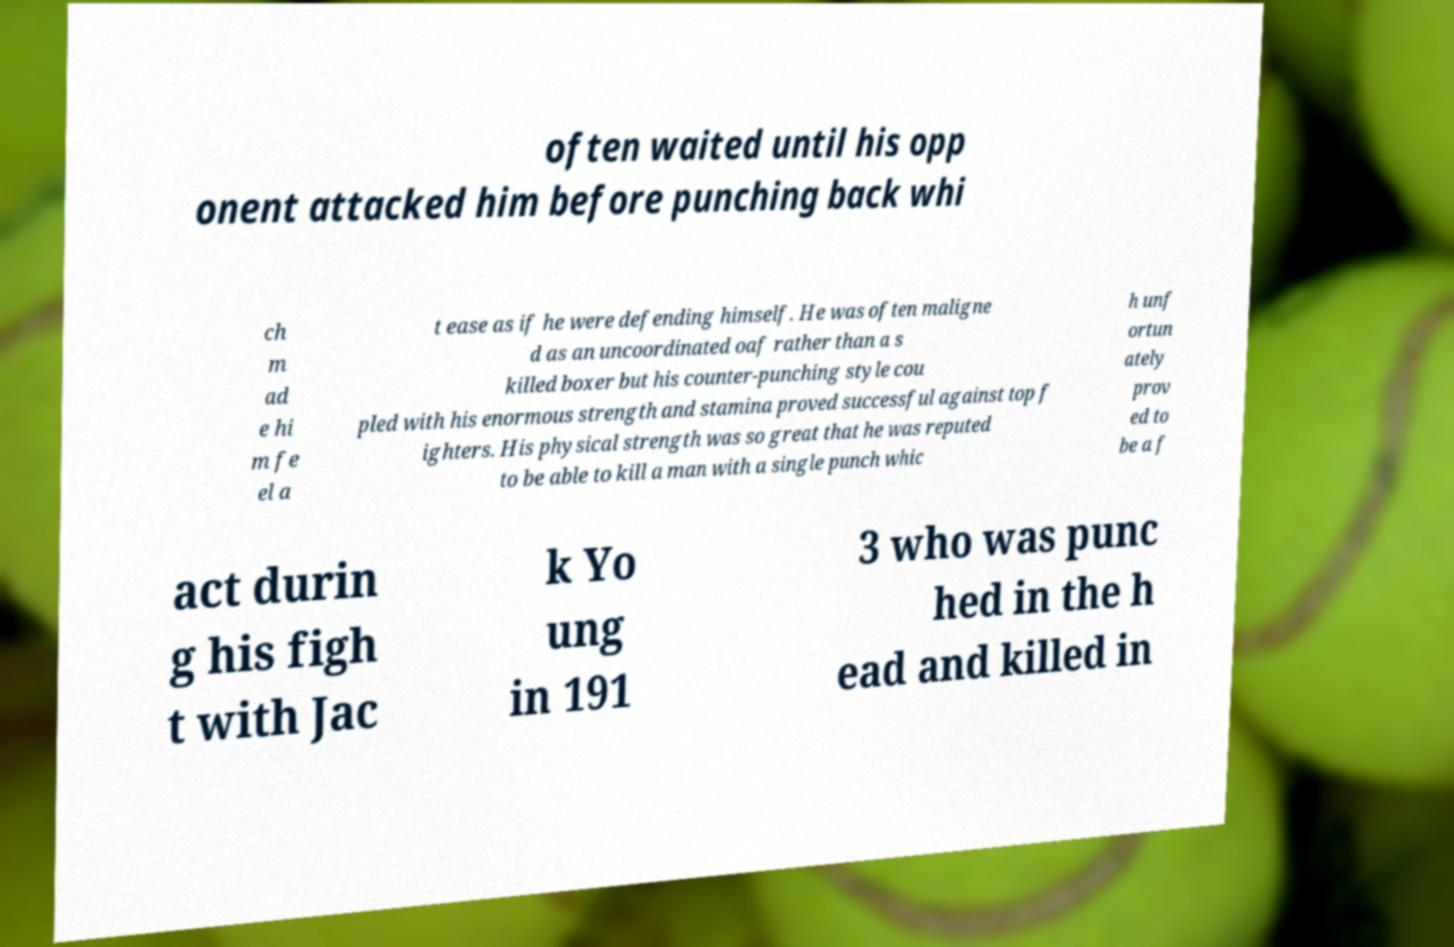I need the written content from this picture converted into text. Can you do that? often waited until his opp onent attacked him before punching back whi ch m ad e hi m fe el a t ease as if he were defending himself. He was often maligne d as an uncoordinated oaf rather than a s killed boxer but his counter-punching style cou pled with his enormous strength and stamina proved successful against top f ighters. His physical strength was so great that he was reputed to be able to kill a man with a single punch whic h unf ortun ately prov ed to be a f act durin g his figh t with Jac k Yo ung in 191 3 who was punc hed in the h ead and killed in 